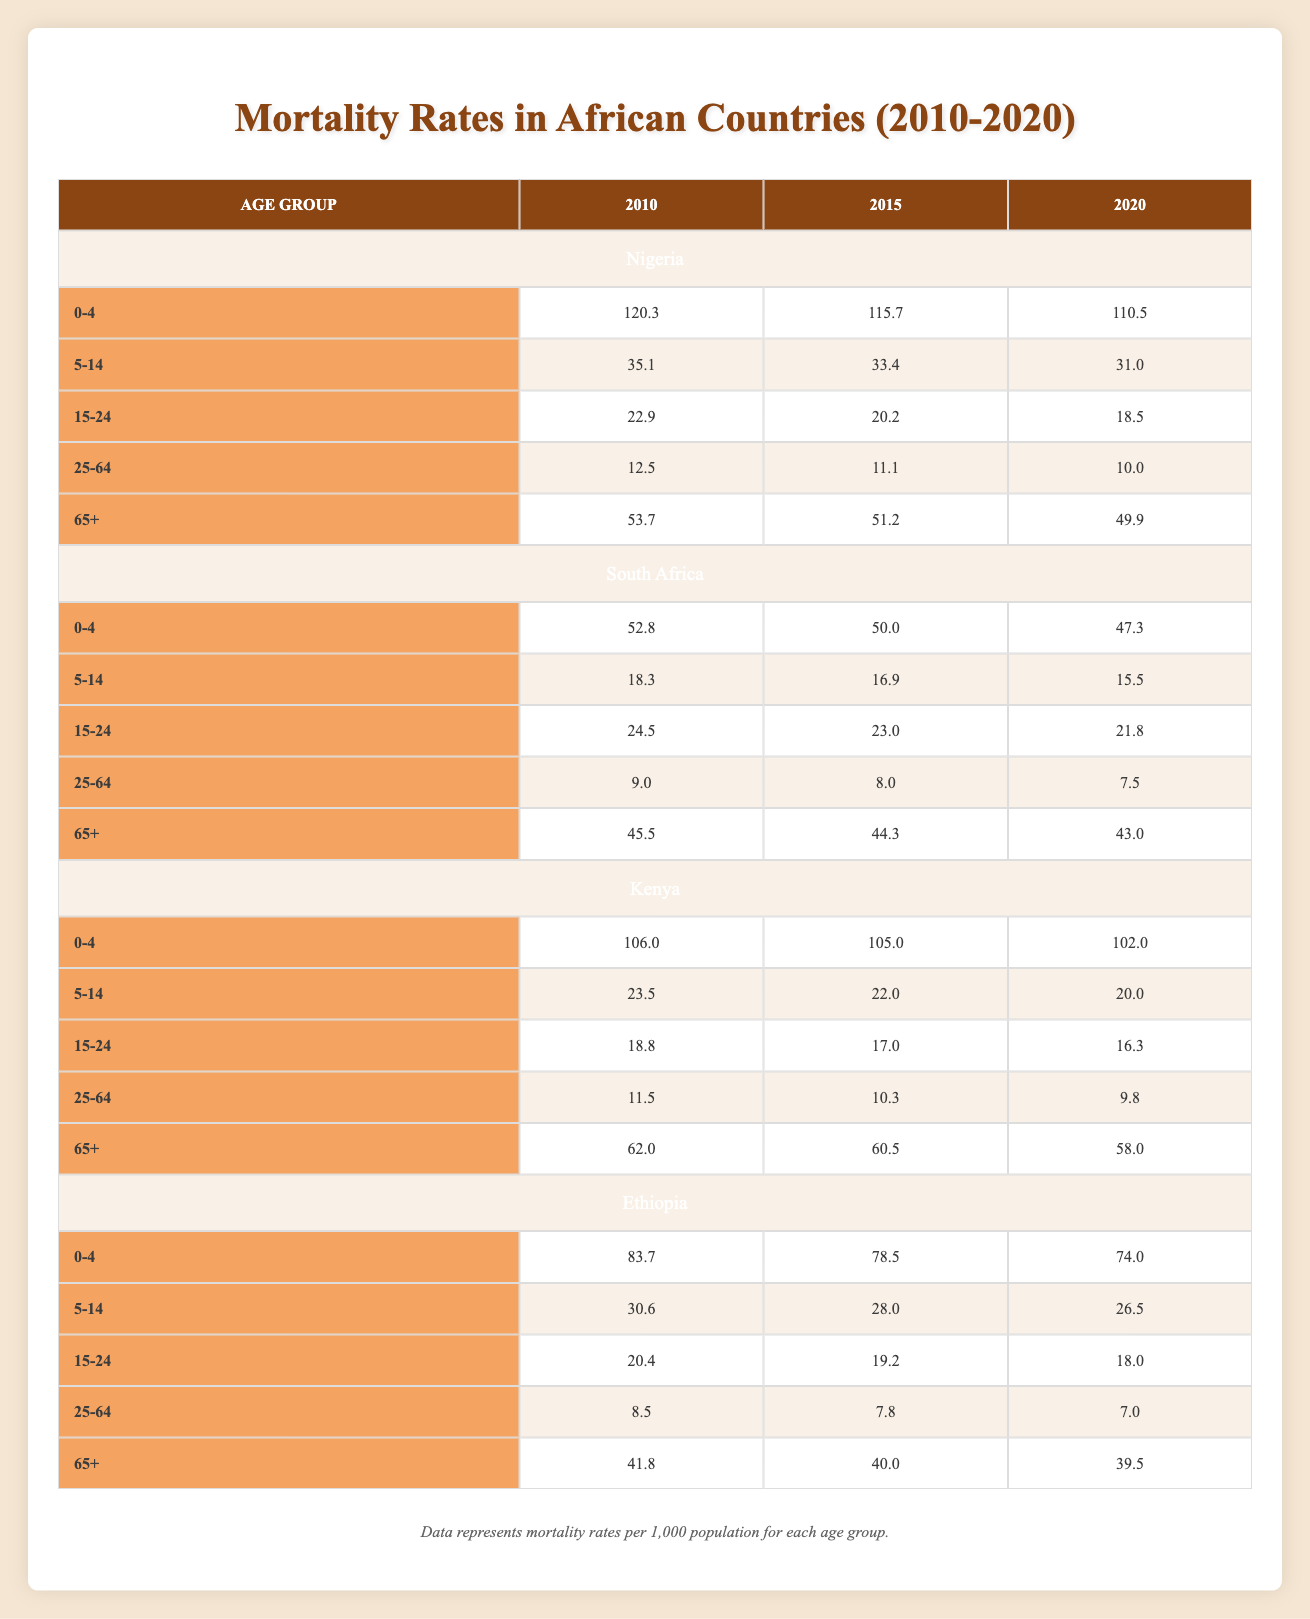What were the mortality rates for the age group 5-14 in Nigeria in 2020? According to the table, the mortality rate for the age group 5-14 in Nigeria in 2020 is 31.0.
Answer: 31.0 What is the overall trend in the mortality rates for the age group 0-4 in South Africa from 2010 to 2020? The table shows that the mortality rate for the age group 0-4 in South Africa decreased from 52.8 in 2010 to 47.3 in 2020, indicating a downward trend.
Answer: Downward trend What was the highest mortality rate recorded for the age group 65+ among the countries in 2010? By examining the 65+ age group for all countries in 2010, Nigeria had the highest mortality rate at 53.7 compared to South Africa (45.5), Kenya (62.0), and Ethiopia (41.8).
Answer: Nigeria 53.7 What is the average mortality rate for the 25-64 age group across all countries in 2015? The mortality rates for the 25-64 age group in 2015 are: Nigeria (11.1), South Africa (8.0), Kenya (10.3), and Ethiopia (7.8). Adding these gives 11.1 + 8.0 + 10.3 + 7.8 = 37.2. There are 4 countries, so the average is 37.2 / 4 = 9.3.
Answer: 9.3 Is the mortality rate for the age group 15-24 higher in Kenya than in Nigeria in 2015? In 2015, the mortality rate for the age group 15-24 in Kenya is 17.0 while in Nigeria it is 20.2. Since 17.0 is less than 20.2, the statement is false.
Answer: No What was the difference in mortality rates for the age group 0-4 between Ethiopia and Kenya in 2020? In 2020, Ethiopia had a mortality rate of 74.0 and Kenya had a rate of 102.0 for the age group 0-4. The difference is 102.0 - 74.0 = 28.0.
Answer: 28.0 Which country had the lowest mortality rate in the age group 25-64 in 2020? The mortality rates for 25-64 in 2020 are: Nigeria (10.0), South Africa (7.5), Kenya (9.8), and Ethiopia (7.0). The lowest is Ethiopia at 7.0.
Answer: Ethiopia 7.0 Was there a decrease in mortality rate for the age group 5-14 in all countries from 2010 to 2020? The mortality rates for 5-14 in 2010 and 2020 are as follows: Nigeria (35.1 to 31.0), South Africa (18.3 to 15.5), Kenya (23.5 to 20.0), and Ethiopia (30.6 to 26.5). All countries show a decrease in this age group.
Answer: Yes What are the overall mortality rates for the age group 65+ in South Africa across the years? The mortality rates for the age group 65 in South Africa across the years are: 2010 (45.5), 2015 (44.3), and 2020 (43.0). This indicates a gradual decrease in mortality rates over the years.
Answer: Gradual decrease 